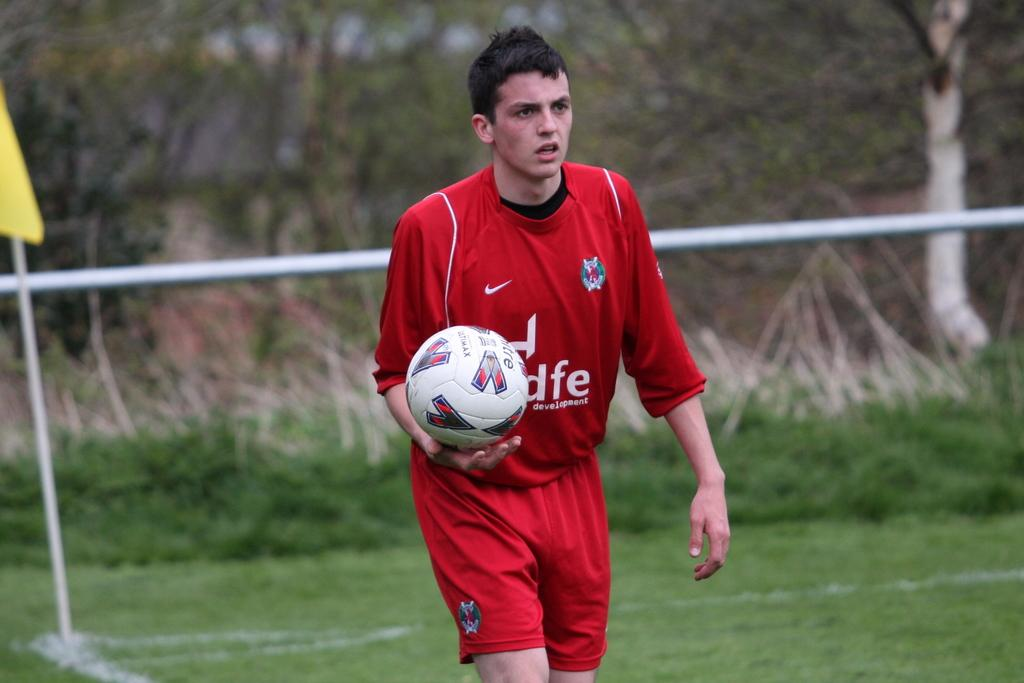Who is present in the image? There is a man in the image. What is the man holding in his hand? The man is holding a ball in his hand. What type of surface is visible in the image? There is grass visible in the image. What can be seen in the background of the image? There are trees in the background of the image. How many oranges are visible in the image? There are no oranges present in the image. What type of passenger is the man in the image? The image does not depict any passengers, as it only features a man holding a ball. 